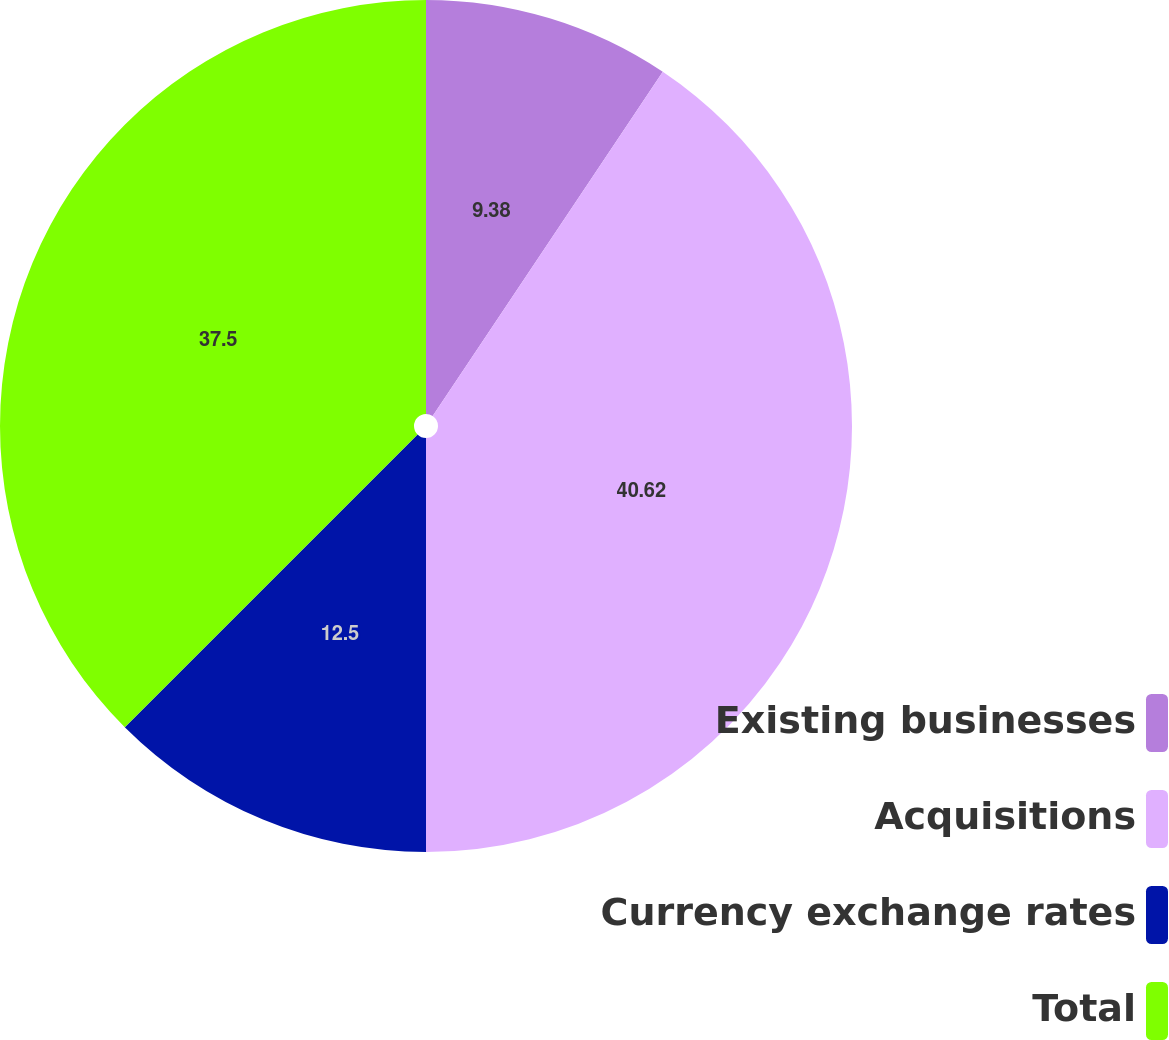Convert chart to OTSL. <chart><loc_0><loc_0><loc_500><loc_500><pie_chart><fcel>Existing businesses<fcel>Acquisitions<fcel>Currency exchange rates<fcel>Total<nl><fcel>9.38%<fcel>40.62%<fcel>12.5%<fcel>37.5%<nl></chart> 